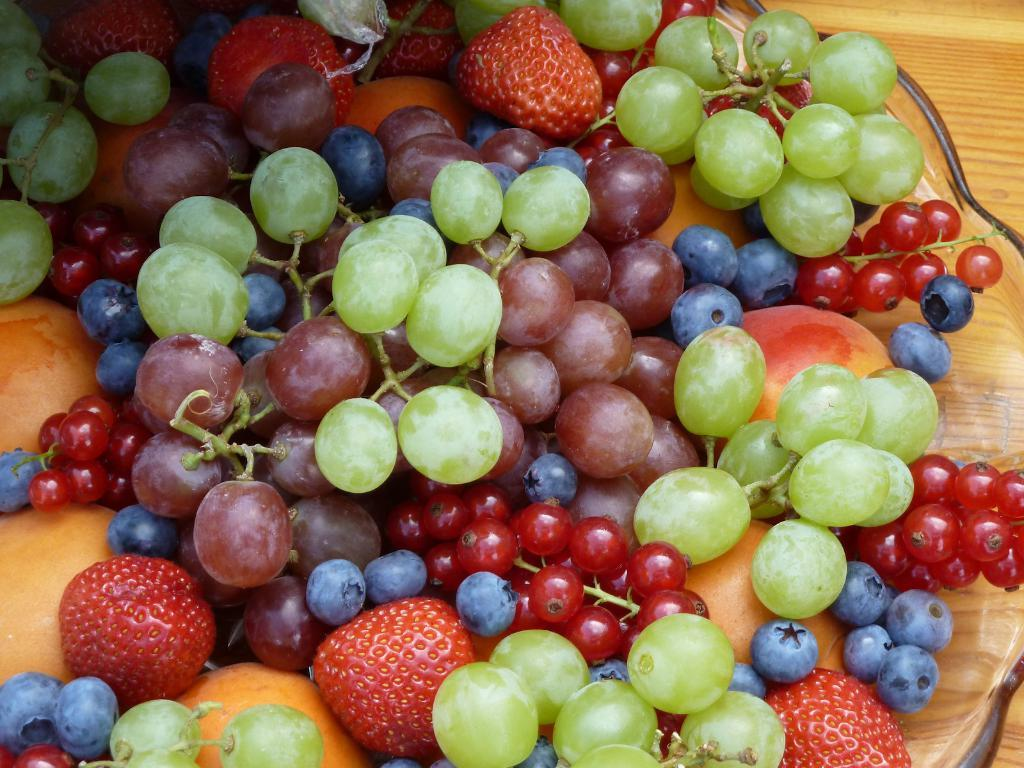What type of food can be seen in the image? There are fruits in the image. How are the fruits arranged or displayed? The fruits are on a glass utensil. What is the surface beneath the glass utensil made of? The glass utensil is placed on a wooden surface. What type of joke is being told by the fruits in the image? There is no joke being told by the fruits in the image, as fruits do not have the ability to tell jokes. 